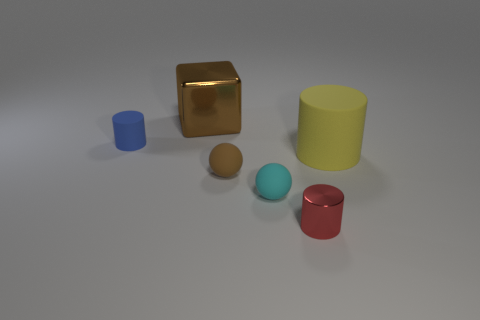Add 2 blue things. How many objects exist? 8 Subtract all blocks. How many objects are left? 5 Add 4 blue objects. How many blue objects are left? 5 Add 1 tiny metal things. How many tiny metal things exist? 2 Subtract 0 blue blocks. How many objects are left? 6 Subtract all balls. Subtract all big yellow shiny blocks. How many objects are left? 4 